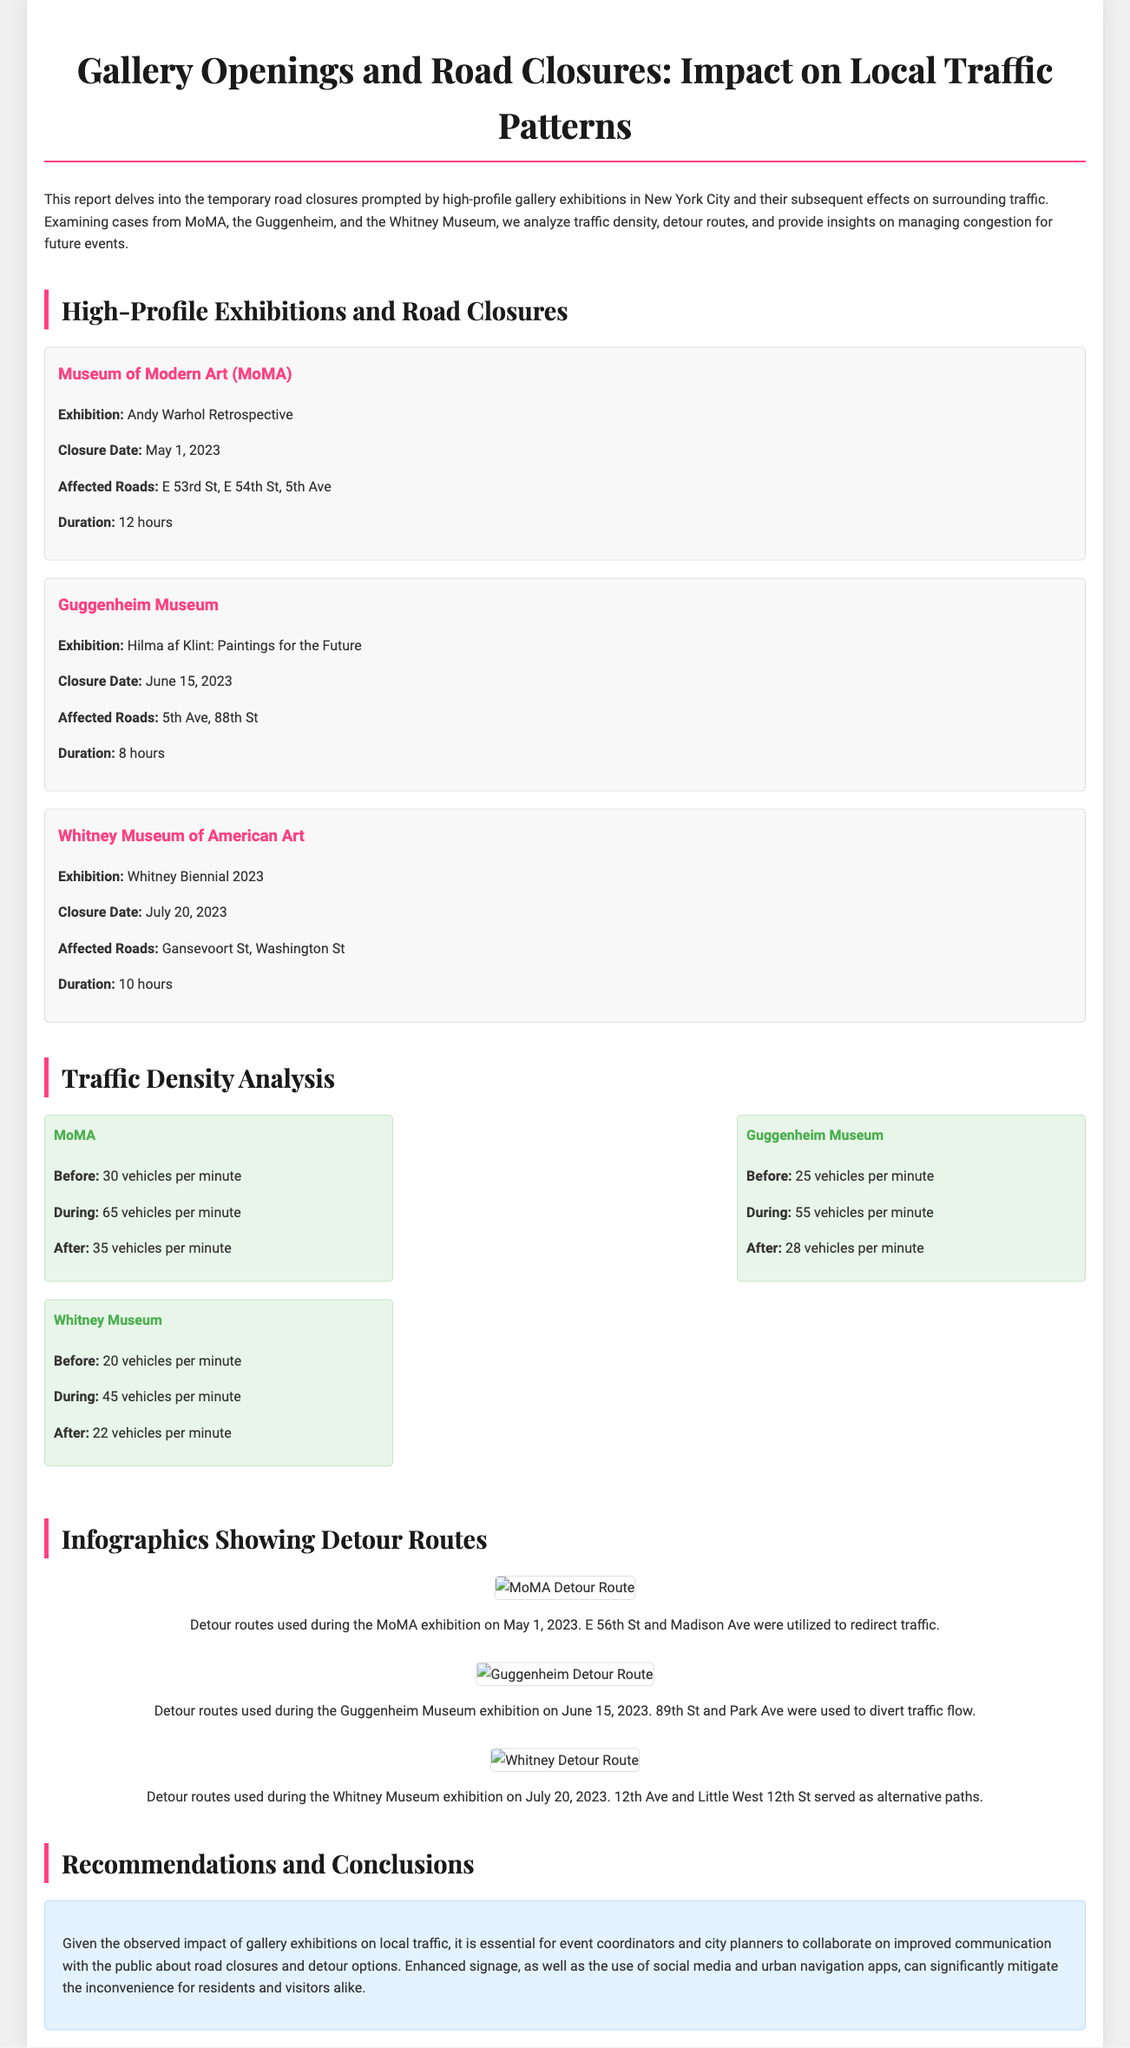what is the exhibition title at MoMA? The exhibition title is mentioned in the specific event section detailing the MoMA exhibition, which is "Andy Warhol Retrospective."
Answer: Andy Warhol Retrospective when did the Guggenheim's exhibition occur? The closure date for the Guggenheim exhibition is specified in the event section, which is June 15, 2023.
Answer: June 15, 2023 how long was the road closure during the Whitney Museum's exhibition? The duration of the closure is stated for the Whitney Museum exhibition, which lasted for 10 hours.
Answer: 10 hours what was the traffic density during the MoMA exhibition? The traffic density readings are provided, specifically stating "65 vehicles per minute" during the MoMA exhibition.
Answer: 65 vehicles per minute which roads were affected by the Guggenheim's exhibition? The affected roads during the Guggenheim exhibition are listed as "5th Ave, 88th St."
Answer: 5th Ave, 88th St what detour routes were utilized for the MoMA exhibition? Detour routes are mentioned specifically for the MoMA exhibition; they were E 56th St and Madison Ave.
Answer: E 56th St and Madison Ave what was the traffic density before the Whitney Museum's exhibition? The document provides the traffic density before the Whitney exhibition, which is stated as "20 vehicles per minute."
Answer: 20 vehicles per minute how many vehicles per minute were recorded after the MoMA exhibition? The post-event traffic density for MoMA is highlighted in the data, indicated as "35 vehicles per minute."
Answer: 35 vehicles per minute what is one recommendation for managing future traffic during gallery events? The report gives recommendations including improving communication about closures, as per the concluding section.
Answer: Improved communication 